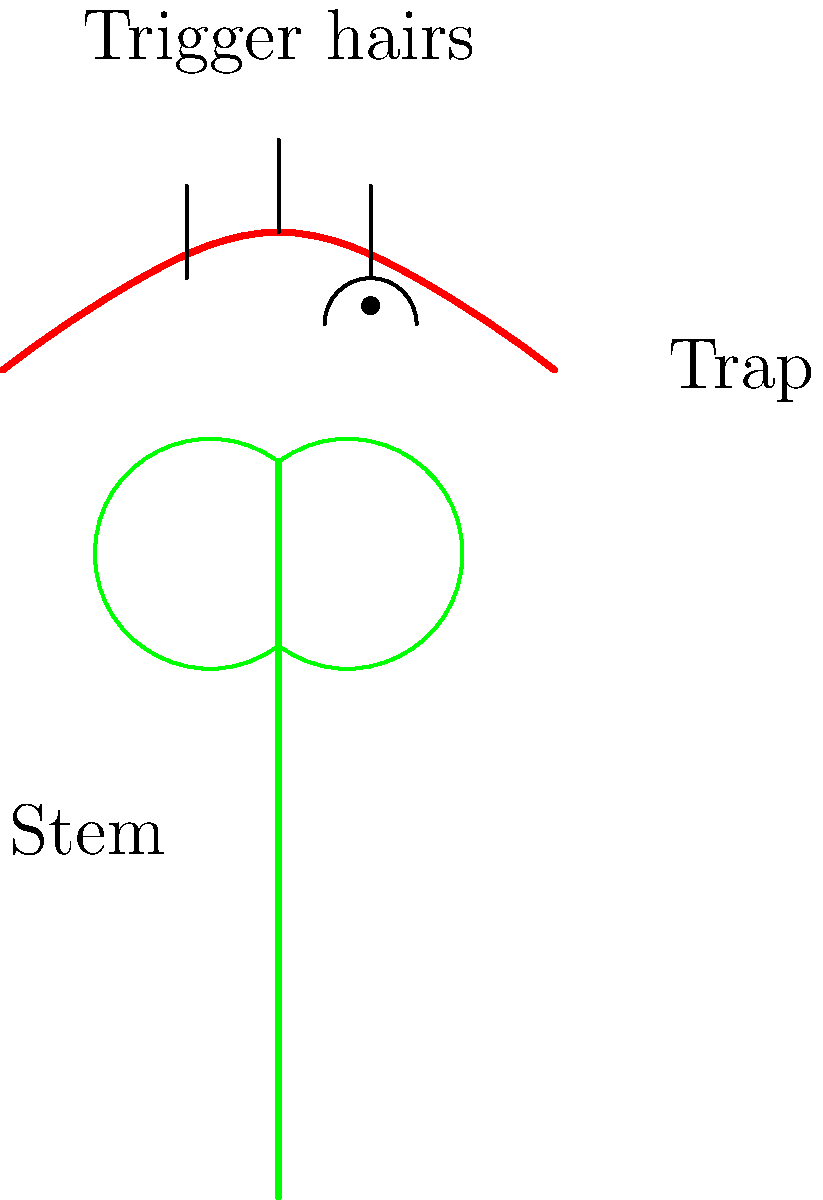In the insectivorous plant Drosera burmannii, commonly found in Jharkhand, what is the primary biomechanical principle behind the rapid closure of its leaf traps when prey touches the trigger hairs? To understand the biomechanics of Drosera burmannii's trap closure, let's break it down step-by-step:

1. Trap structure: The leaves of D. burmannii are modified into trap-like structures with sensitive trigger hairs on the surface.

2. Resting state: In the resting state, the trap is open and the leaf cells are turgid (full of water).

3. Stimulation: When an insect touches the trigger hairs, it causes a rapid change in the plant's cells.

4. Action potential: The touch stimulus generates an action potential, similar to nerve impulses in animals.

5. Ion movement: The action potential triggers the movement of ions, primarily potassium (K+) and chloride (Cl-), across cell membranes.

6. Water movement: The ion movement causes a rapid shift of water out of specific cells in the trap, following osmotic gradients.

7. Cell deformation: As water leaves these cells, they quickly lose turgor pressure and deform.

8. Elastic instability: The coordinated deformation of multiple cells creates an elastic instability in the leaf structure.

9. Snap-buckling: This instability leads to a phenomenon called snap-buckling, where the leaf rapidly changes from a convex to a concave shape.

10. Trap closure: The snap-buckling effect causes the trap to close quickly, capturing the prey.

The key principle here is the conversion of stored elastic energy into kinetic energy through the rapid loss of turgor pressure and subsequent snap-buckling.
Answer: Snap-buckling due to rapid turgor loss 